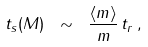Convert formula to latex. <formula><loc_0><loc_0><loc_500><loc_500>t _ { s } ( M ) \ \sim \ \frac { \langle m \rangle } { m } \, t _ { r } \, ,</formula> 